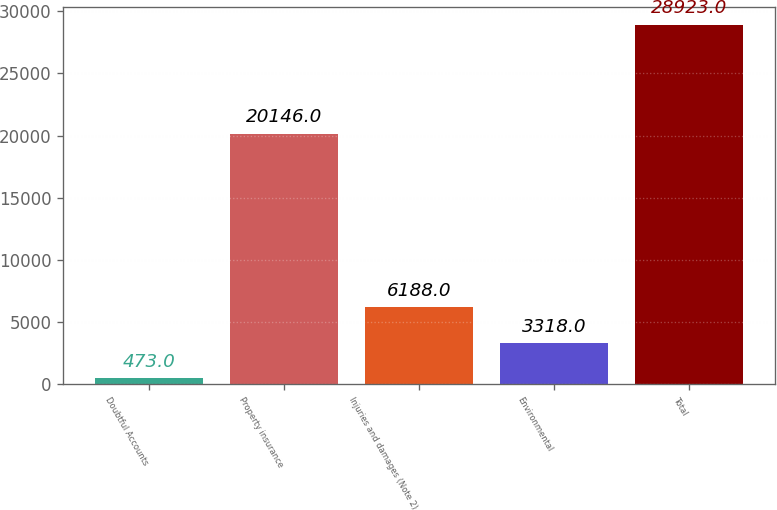Convert chart to OTSL. <chart><loc_0><loc_0><loc_500><loc_500><bar_chart><fcel>Doubtful Accounts<fcel>Property insurance<fcel>Injuries and damages (Note 2)<fcel>Environmental<fcel>Total<nl><fcel>473<fcel>20146<fcel>6188<fcel>3318<fcel>28923<nl></chart> 